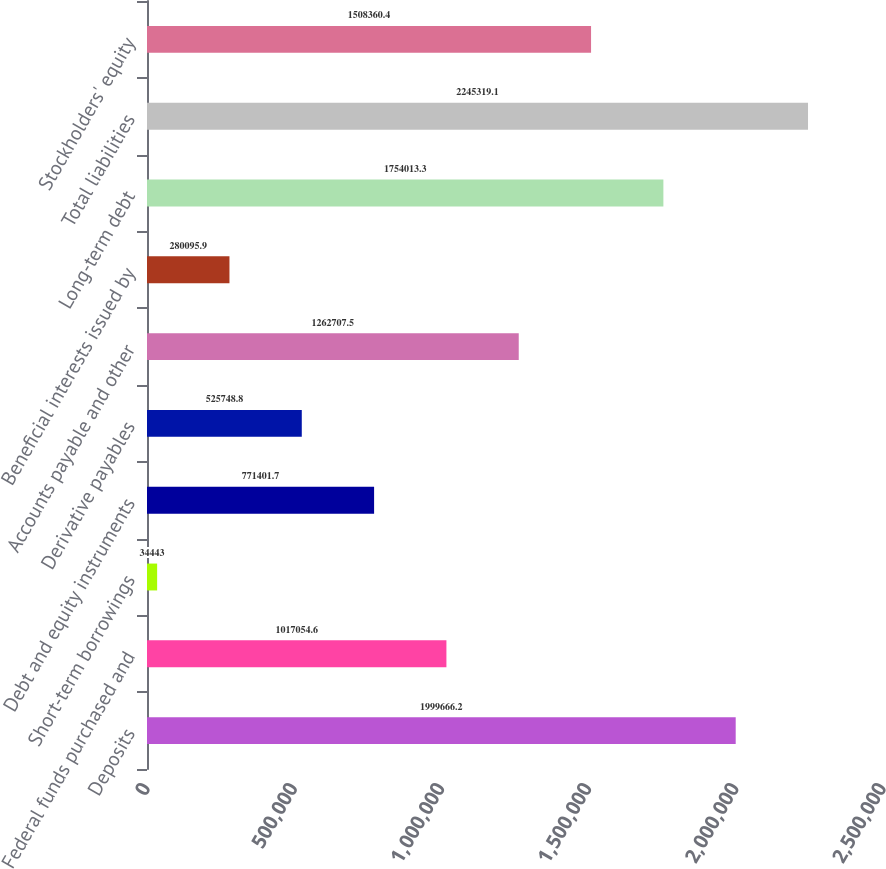Convert chart. <chart><loc_0><loc_0><loc_500><loc_500><bar_chart><fcel>Deposits<fcel>Federal funds purchased and<fcel>Short-term borrowings<fcel>Debt and equity instruments<fcel>Derivative payables<fcel>Accounts payable and other<fcel>Beneficial interests issued by<fcel>Long-term debt<fcel>Total liabilities<fcel>Stockholders' equity<nl><fcel>1.99967e+06<fcel>1.01705e+06<fcel>34443<fcel>771402<fcel>525749<fcel>1.26271e+06<fcel>280096<fcel>1.75401e+06<fcel>2.24532e+06<fcel>1.50836e+06<nl></chart> 